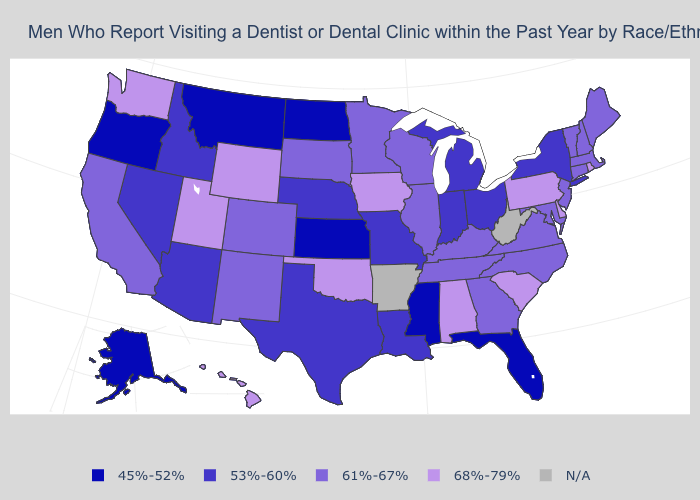Among the states that border Missouri , which have the highest value?
Be succinct. Iowa, Oklahoma. Name the states that have a value in the range 45%-52%?
Concise answer only. Alaska, Florida, Kansas, Mississippi, Montana, North Dakota, Oregon. Which states hav the highest value in the West?
Concise answer only. Hawaii, Utah, Washington, Wyoming. Which states hav the highest value in the South?
Short answer required. Alabama, Delaware, Oklahoma, South Carolina. What is the value of Michigan?
Quick response, please. 53%-60%. What is the value of Pennsylvania?
Concise answer only. 68%-79%. Among the states that border Oklahoma , which have the highest value?
Write a very short answer. Colorado, New Mexico. Name the states that have a value in the range 68%-79%?
Short answer required. Alabama, Delaware, Hawaii, Iowa, Oklahoma, Pennsylvania, Rhode Island, South Carolina, Utah, Washington, Wyoming. Among the states that border Colorado , does Kansas have the highest value?
Short answer required. No. Which states have the highest value in the USA?
Write a very short answer. Alabama, Delaware, Hawaii, Iowa, Oklahoma, Pennsylvania, Rhode Island, South Carolina, Utah, Washington, Wyoming. Among the states that border West Virginia , which have the highest value?
Keep it brief. Pennsylvania. What is the value of Maine?
Answer briefly. 61%-67%. What is the lowest value in the MidWest?
Give a very brief answer. 45%-52%. 